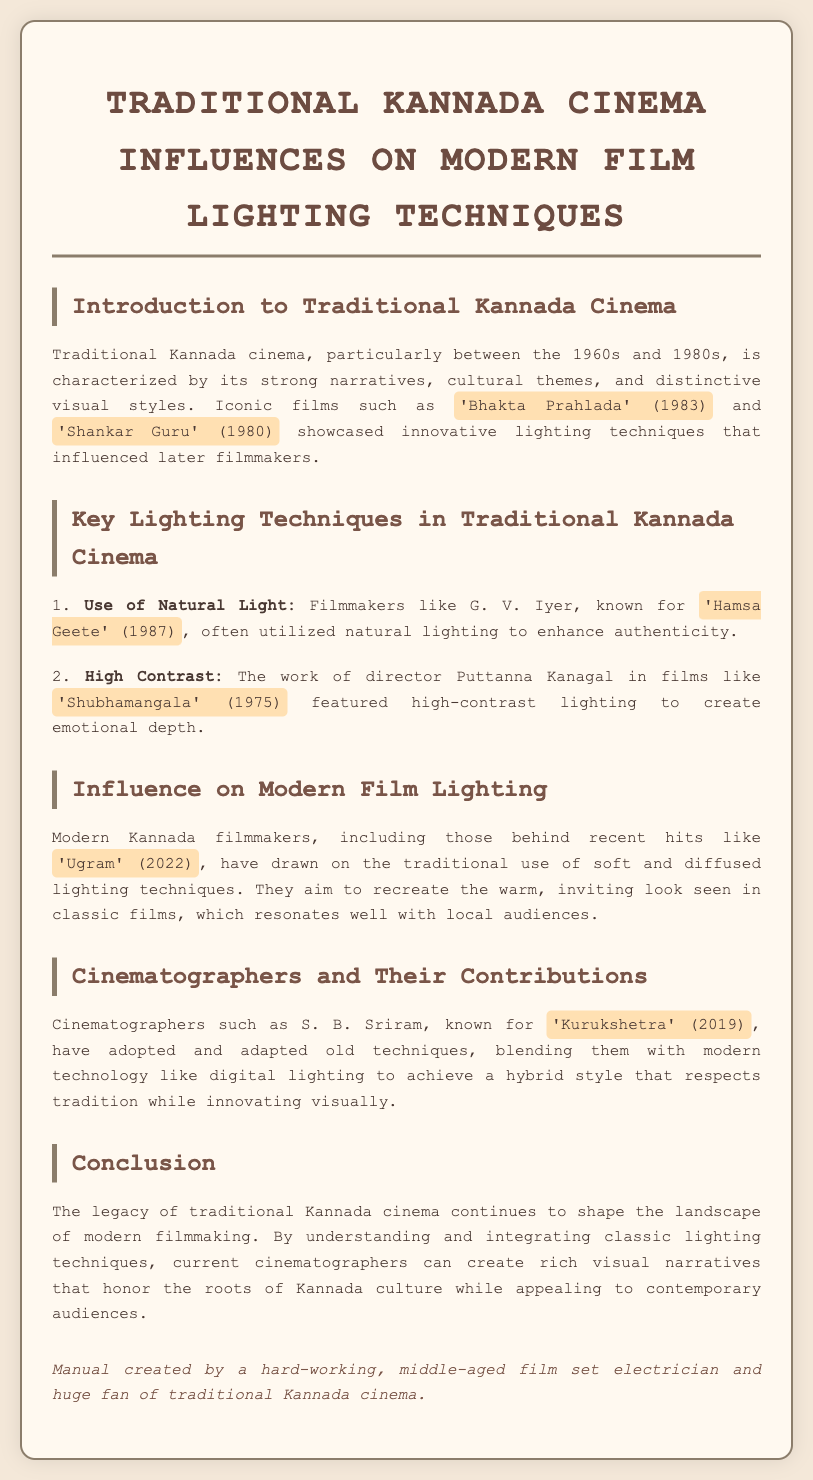What is the primary time period for traditional Kannada cinema? The document states that traditional Kannada cinema is characterized particularly between the 1960s and 1980s.
Answer: 1960s and 1980s Which film is mentioned alongside 'Bhakta Prahlada'? The document lists 'Shankar Guru' as an iconic film along with 'Bhakta Prahlada'.
Answer: 'Shankar Guru' Who utilized natural lighting in traditional Kannada cinema? The manual highlights G. V. Iyer as a filmmaker known for using natural lighting.
Answer: G. V. Iyer What is a key lighting technique associated with Puttanna Kanagal? The document mentions that the use of high contrast is a key lighting technique associated with Puttanna Kanagal.
Answer: High Contrast Which modern film is used as an example of recent hits influenced by traditional techniques? The document cites 'Ugram' as a recent hit that draws on traditional lighting techniques.
Answer: 'Ugram' Who is the cinematographer known for 'Kurukshetra'? The text identifies S. B. Sriram as the cinematographer known for this film.
Answer: S. B. Sriram What type of lighting techniques do modern filmmakers aim to recreate from traditional cinema? The document states that they aim to recreate soft and diffused lighting techniques.
Answer: Soft and diffused lighting What does the conclusion emphasize about traditional Kannada cinema? The conclusion emphasizes that the legacy of traditional Kannada cinema shapes modern filmmaking.
Answer: Shapes modern filmmaking 